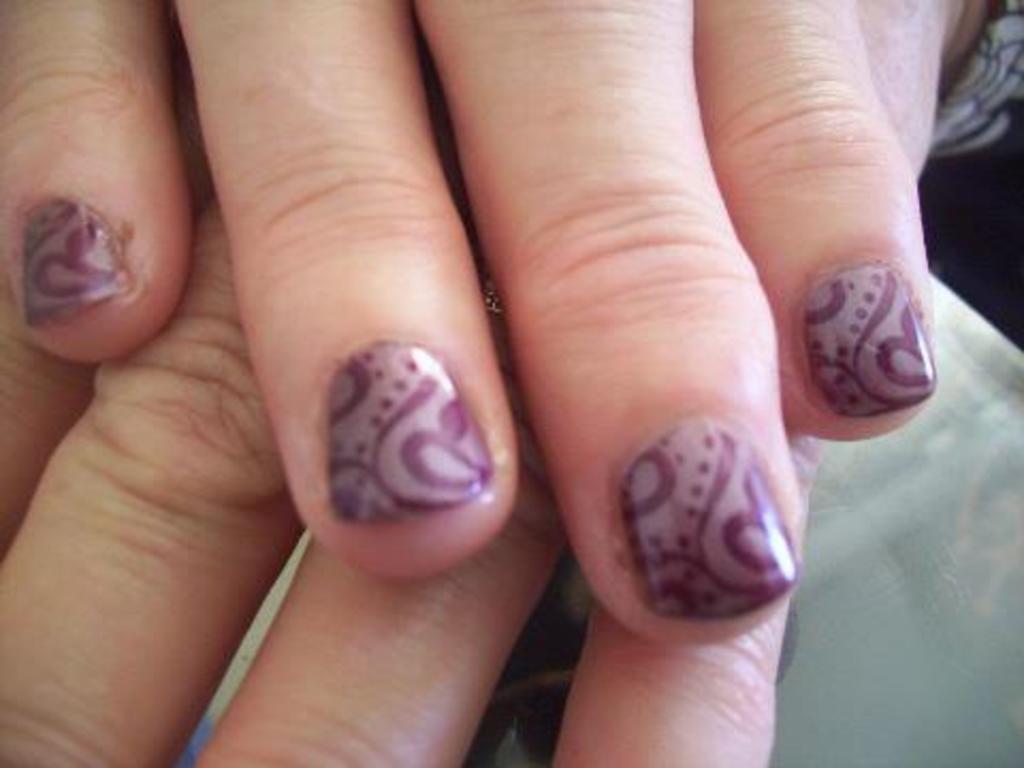Please provide a concise description of this image. In this image I can see the hands of the person on the ash color surface. I can see the black background. 